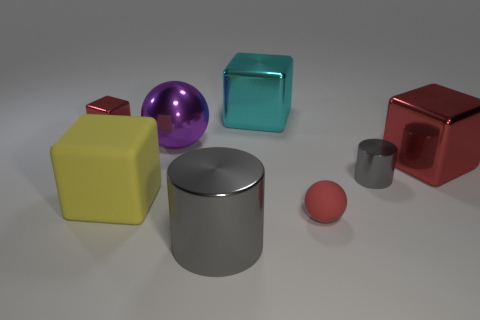Subtract all metallic blocks. How many blocks are left? 1 Add 2 big metallic cubes. How many objects exist? 10 Subtract all purple balls. How many balls are left? 1 Add 4 yellow matte blocks. How many yellow matte blocks are left? 5 Add 8 tiny red shiny objects. How many tiny red shiny objects exist? 9 Subtract 0 green balls. How many objects are left? 8 Subtract all balls. How many objects are left? 6 Subtract 2 cylinders. How many cylinders are left? 0 Subtract all purple cubes. Subtract all cyan balls. How many cubes are left? 4 Subtract all green blocks. How many purple balls are left? 1 